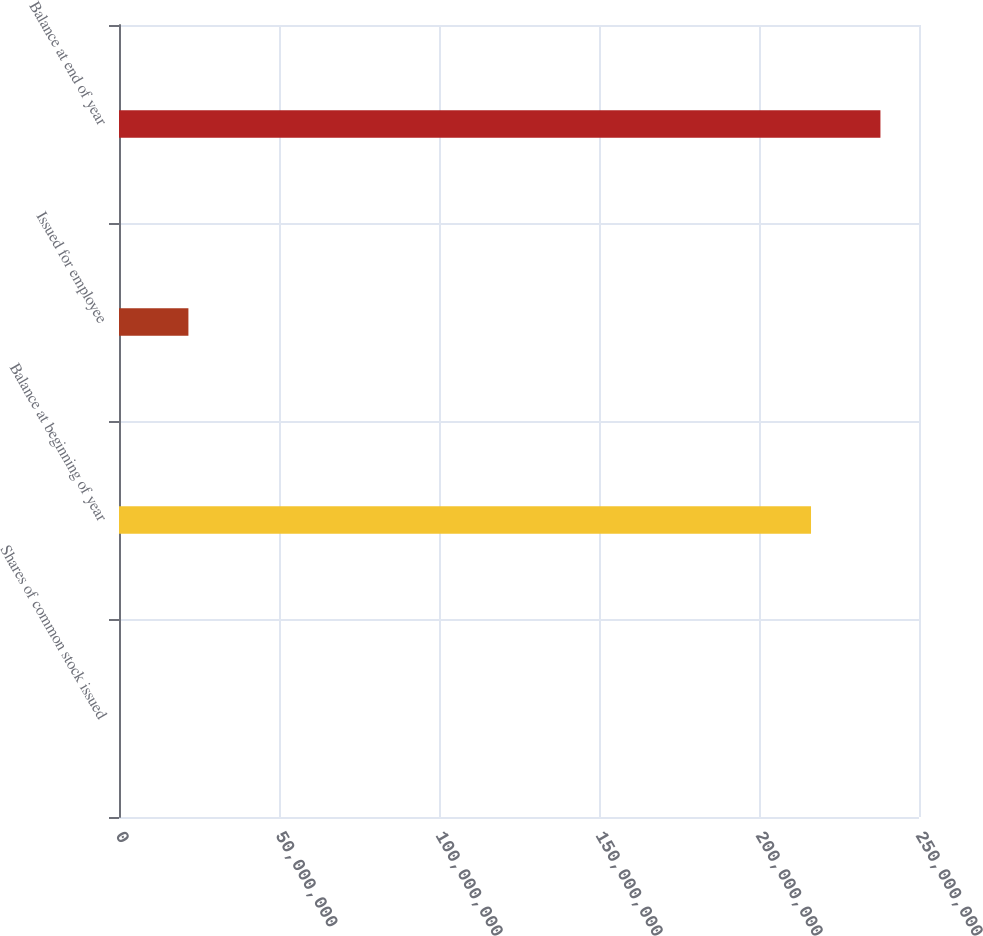<chart> <loc_0><loc_0><loc_500><loc_500><bar_chart><fcel>Shares of common stock issued<fcel>Balance at beginning of year<fcel>Issued for employee<fcel>Balance at end of year<nl><fcel>2015<fcel>2.16257e+08<fcel>2.16918e+07<fcel>2.37947e+08<nl></chart> 